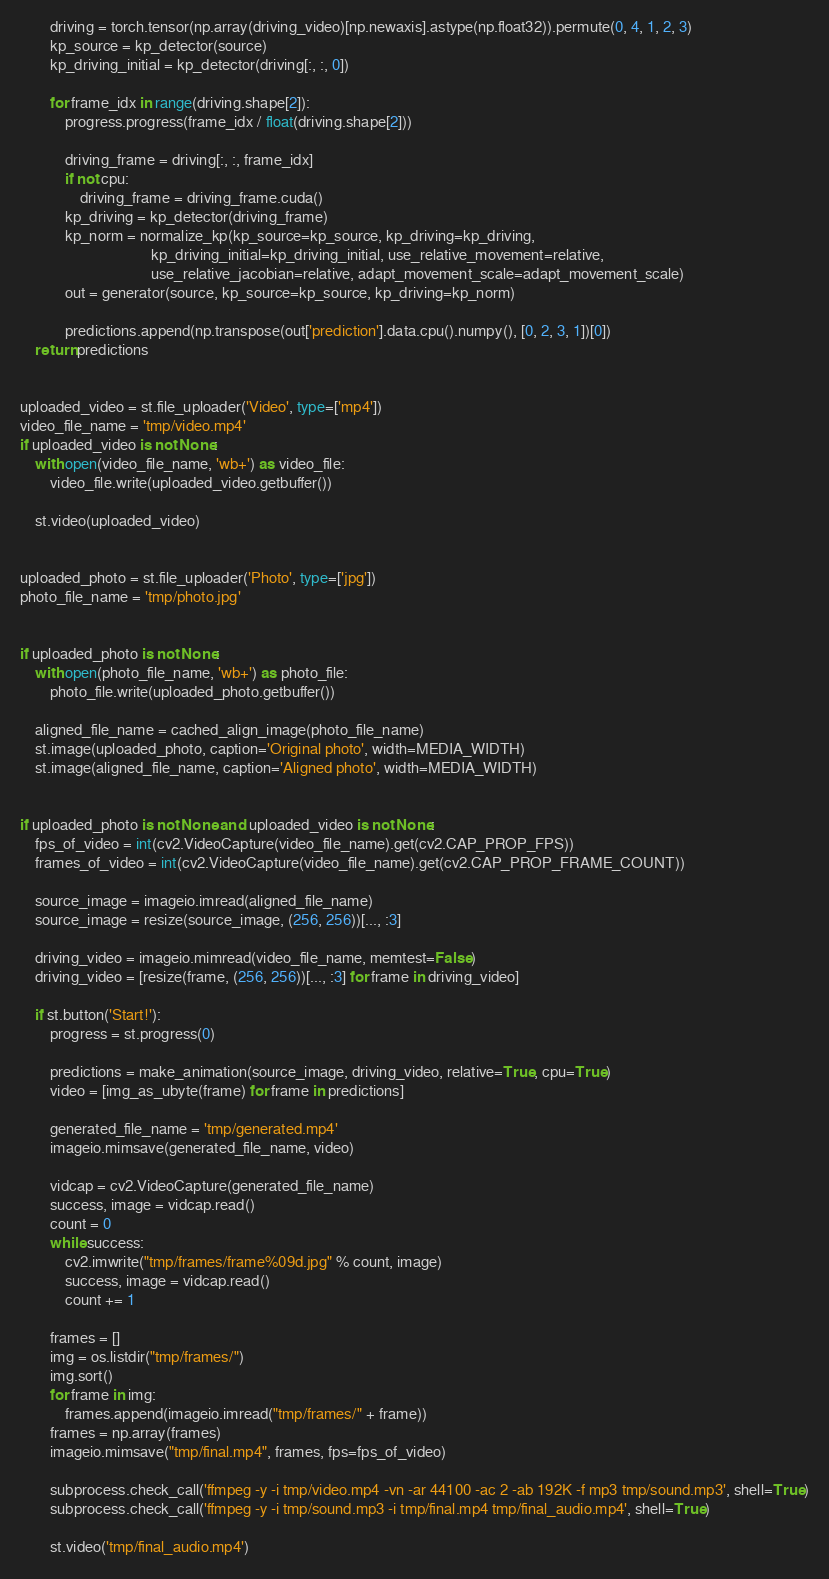<code> <loc_0><loc_0><loc_500><loc_500><_Python_>        driving = torch.tensor(np.array(driving_video)[np.newaxis].astype(np.float32)).permute(0, 4, 1, 2, 3)
        kp_source = kp_detector(source)
        kp_driving_initial = kp_detector(driving[:, :, 0])

        for frame_idx in range(driving.shape[2]):
            progress.progress(frame_idx / float(driving.shape[2]))

            driving_frame = driving[:, :, frame_idx]
            if not cpu:
                driving_frame = driving_frame.cuda()
            kp_driving = kp_detector(driving_frame)
            kp_norm = normalize_kp(kp_source=kp_source, kp_driving=kp_driving,
                                   kp_driving_initial=kp_driving_initial, use_relative_movement=relative,
                                   use_relative_jacobian=relative, adapt_movement_scale=adapt_movement_scale)
            out = generator(source, kp_source=kp_source, kp_driving=kp_norm)

            predictions.append(np.transpose(out['prediction'].data.cpu().numpy(), [0, 2, 3, 1])[0])
    return predictions


uploaded_video = st.file_uploader('Video', type=['mp4'])
video_file_name = 'tmp/video.mp4'
if uploaded_video is not None:
    with open(video_file_name, 'wb+') as video_file:
        video_file.write(uploaded_video.getbuffer())

    st.video(uploaded_video)


uploaded_photo = st.file_uploader('Photo', type=['jpg'])
photo_file_name = 'tmp/photo.jpg'


if uploaded_photo is not None:
    with open(photo_file_name, 'wb+') as photo_file:
        photo_file.write(uploaded_photo.getbuffer())

    aligned_file_name = cached_align_image(photo_file_name)
    st.image(uploaded_photo, caption='Original photo', width=MEDIA_WIDTH)
    st.image(aligned_file_name, caption='Aligned photo', width=MEDIA_WIDTH)


if uploaded_photo is not None and uploaded_video is not None:
    fps_of_video = int(cv2.VideoCapture(video_file_name).get(cv2.CAP_PROP_FPS))
    frames_of_video = int(cv2.VideoCapture(video_file_name).get(cv2.CAP_PROP_FRAME_COUNT))

    source_image = imageio.imread(aligned_file_name)
    source_image = resize(source_image, (256, 256))[..., :3]

    driving_video = imageio.mimread(video_file_name, memtest=False)
    driving_video = [resize(frame, (256, 256))[..., :3] for frame in driving_video]

    if st.button('Start!'):
        progress = st.progress(0)

        predictions = make_animation(source_image, driving_video, relative=True, cpu=True)
        video = [img_as_ubyte(frame) for frame in predictions]

        generated_file_name = 'tmp/generated.mp4'
        imageio.mimsave(generated_file_name, video)

        vidcap = cv2.VideoCapture(generated_file_name)
        success, image = vidcap.read()
        count = 0
        while success:
            cv2.imwrite("tmp/frames/frame%09d.jpg" % count, image)
            success, image = vidcap.read()
            count += 1

        frames = []
        img = os.listdir("tmp/frames/")
        img.sort()
        for frame in img:
            frames.append(imageio.imread("tmp/frames/" + frame))
        frames = np.array(frames)
        imageio.mimsave("tmp/final.mp4", frames, fps=fps_of_video)

        subprocess.check_call('ffmpeg -y -i tmp/video.mp4 -vn -ar 44100 -ac 2 -ab 192K -f mp3 tmp/sound.mp3', shell=True)
        subprocess.check_call('ffmpeg -y -i tmp/sound.mp3 -i tmp/final.mp4 tmp/final_audio.mp4', shell=True)

        st.video('tmp/final_audio.mp4')
</code> 